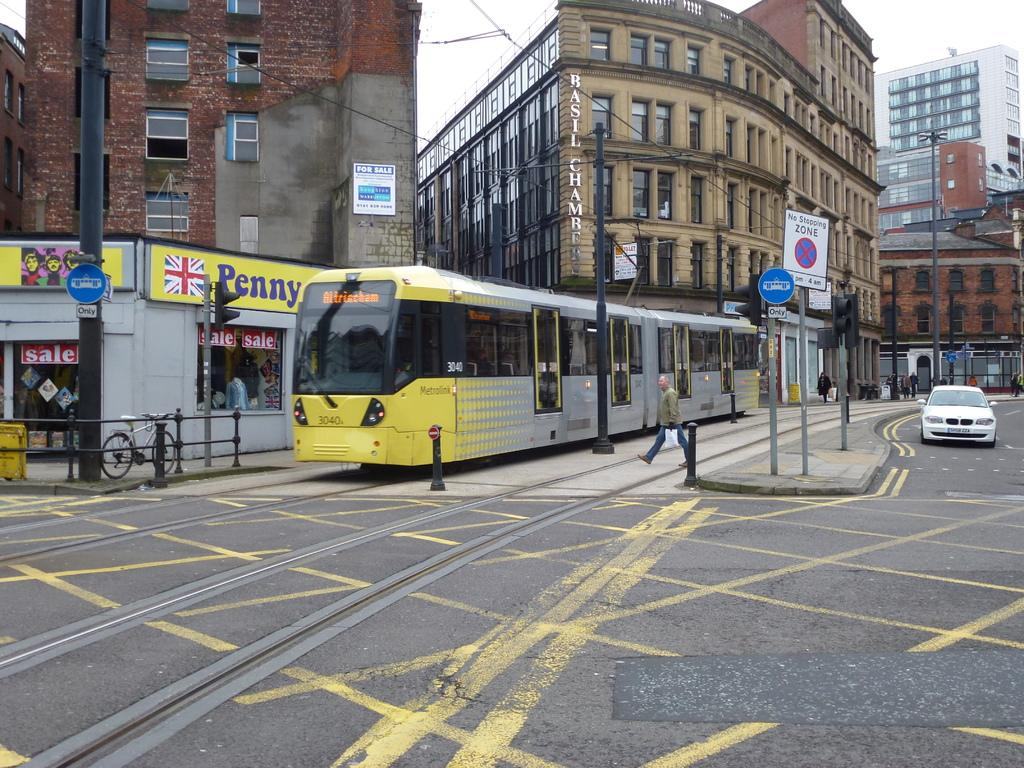What can be seen moving on the road in the image? There are vehicles on the road in the image. What type of information might be conveyed by the sign boards on poles? The sign boards on poles might convey information about directions, rules, or advertisements. What is the bicycle positioned near in the image? The bicycle is beside a fence in the image. What architectural feature can be seen on the buildings in the image? There are windows visible on the buildings in the image. What is the person in the image doing? A person is walking in the image. What type of large-scale advertisements can be seen in the image? There are hoardings visible in the image. How many parcels is the person carrying while walking in the image? There is no parcel visible in the image; the person is simply walking. What type of learning material is being taught by the police in the image? There are no police or learning materials present in the image. 